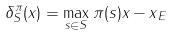Convert formula to latex. <formula><loc_0><loc_0><loc_500><loc_500>\delta _ { S } ^ { \pi } ( x ) = \max _ { s \in S } \| \pi ( s ) x - x \| _ { E }</formula> 